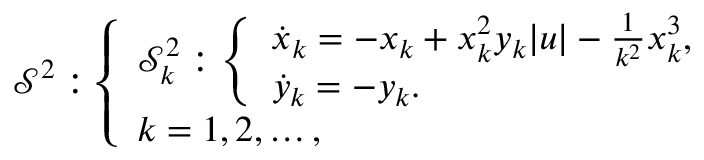Convert formula to latex. <formula><loc_0><loc_0><loc_500><loc_500>\begin{array} { r } { { \mathcal { S } } ^ { 2 } \colon \left \{ \begin{array} { l } { { \mathcal { S } } _ { k } ^ { 2 } \colon \left \{ \begin{array} { l } { \dot { x } _ { k } = - x _ { k } + x _ { k } ^ { 2 } y _ { k } | u | - \frac { 1 } { k ^ { 2 } } x _ { k } ^ { 3 } , } \\ { \dot { y } _ { k } = - y _ { k } . } \end{array} } \\ { k = 1 , 2 , \dots , } \end{array} } \end{array}</formula> 